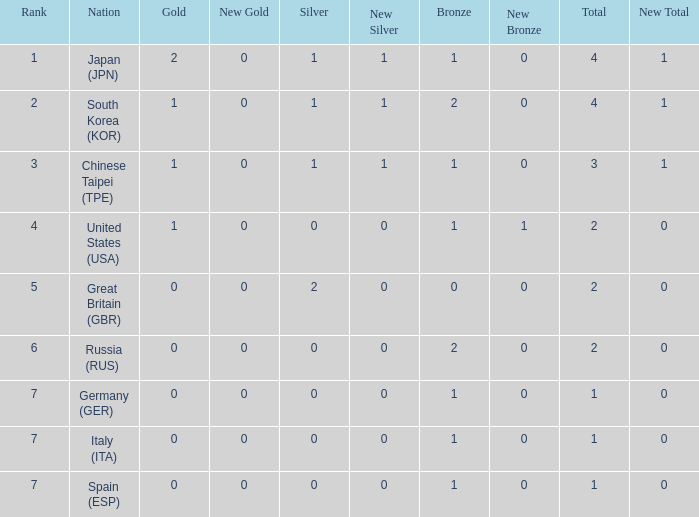What is the smallest number of gold of a country of rank 6, with 2 bronzes? None. 